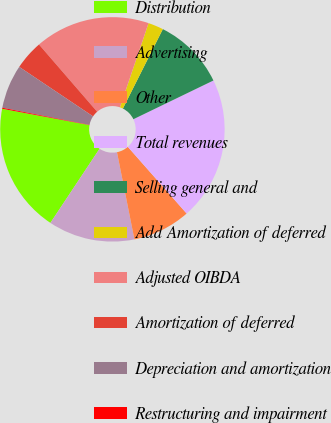Convert chart to OTSL. <chart><loc_0><loc_0><loc_500><loc_500><pie_chart><fcel>Distribution<fcel>Advertising<fcel>Other<fcel>Total revenues<fcel>Selling general and<fcel>Add Amortization of deferred<fcel>Adjusted OIBDA<fcel>Amortization of deferred<fcel>Depreciation and amortization<fcel>Restructuring and impairment<nl><fcel>18.62%<fcel>12.46%<fcel>8.36%<fcel>20.67%<fcel>10.41%<fcel>2.2%<fcel>16.57%<fcel>4.25%<fcel>6.31%<fcel>0.15%<nl></chart> 